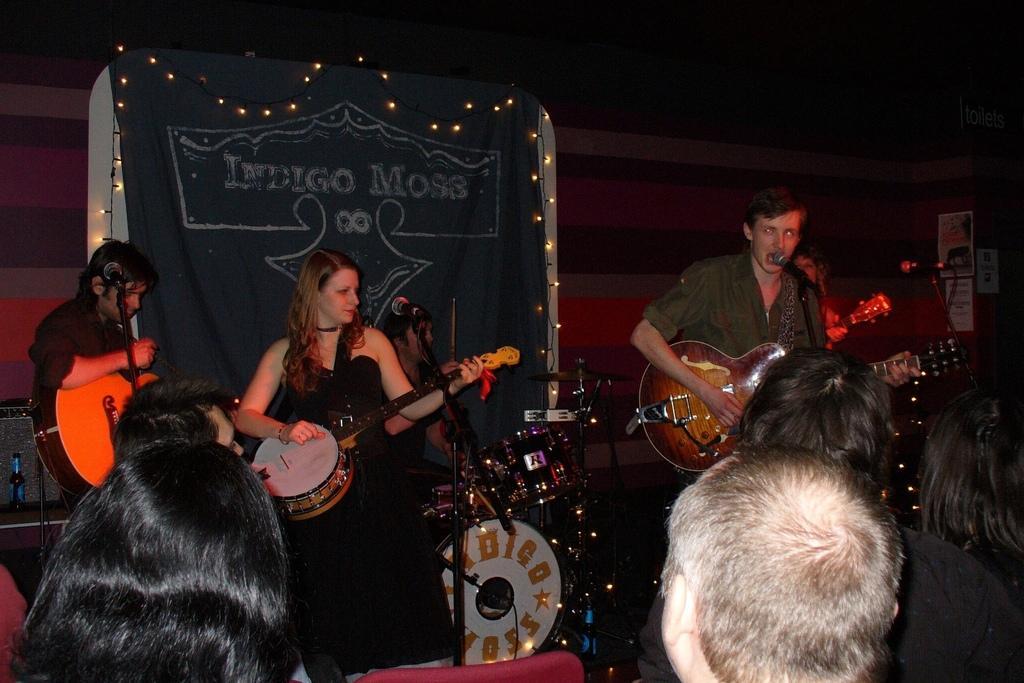Please provide a concise description of this image. There is a band. Man in the front playing guitar and the woman playing a music instrument and the guy over the left side also playing a guitar. There are people looking at them. The background there is a cloth and lights over the top and to the edges. 